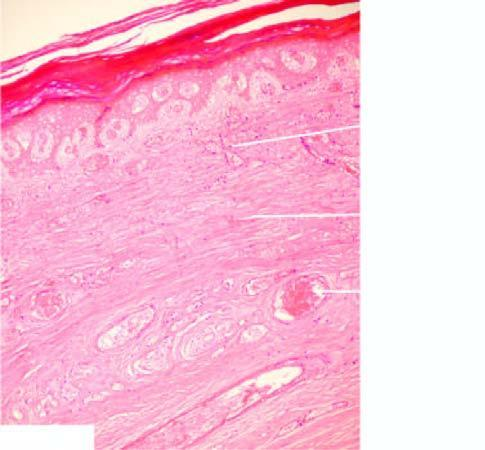does the surrounding zone show coagulativenecrosis of the skin, muscle and other soft tissue, and thrombsed vessels?
Answer the question using a single word or phrase. No 